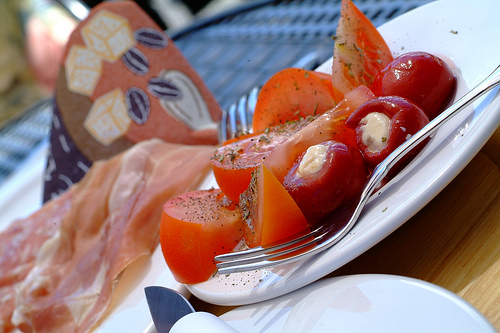<image>
Is the pepper on the tomato? Yes. Looking at the image, I can see the pepper is positioned on top of the tomato, with the tomato providing support. Is there a tomato on the ham? No. The tomato is not positioned on the ham. They may be near each other, but the tomato is not supported by or resting on top of the ham. 